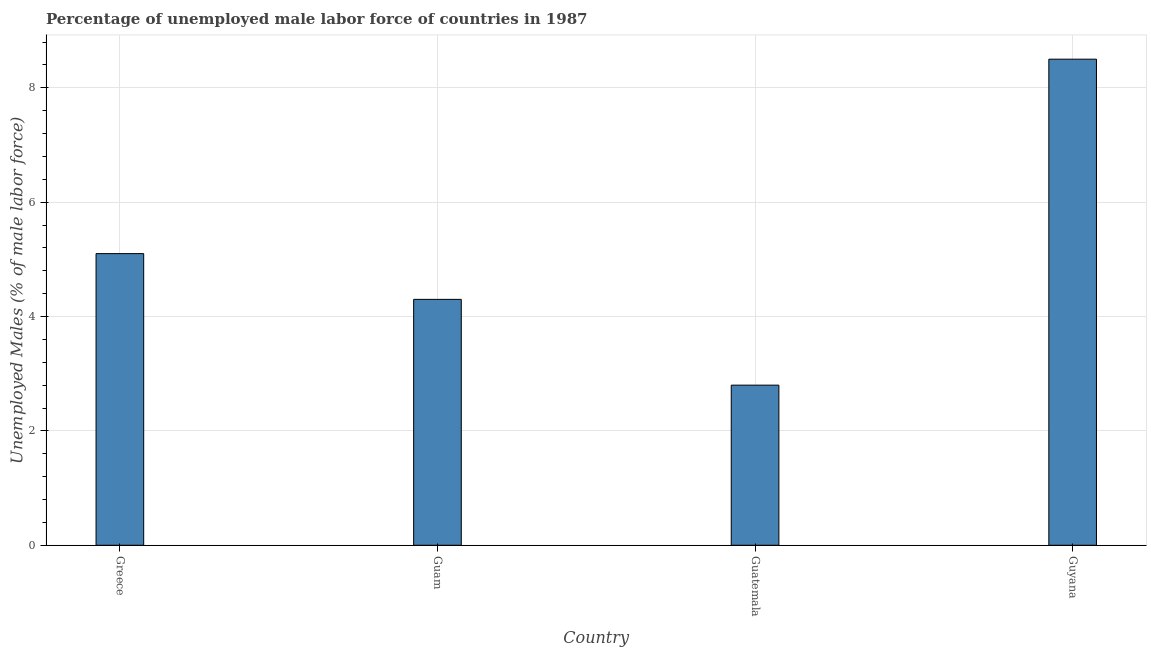What is the title of the graph?
Ensure brevity in your answer.  Percentage of unemployed male labor force of countries in 1987. What is the label or title of the X-axis?
Offer a very short reply. Country. What is the label or title of the Y-axis?
Your answer should be very brief. Unemployed Males (% of male labor force). What is the total unemployed male labour force in Guyana?
Make the answer very short. 8.5. Across all countries, what is the minimum total unemployed male labour force?
Offer a terse response. 2.8. In which country was the total unemployed male labour force maximum?
Provide a succinct answer. Guyana. In which country was the total unemployed male labour force minimum?
Provide a short and direct response. Guatemala. What is the sum of the total unemployed male labour force?
Your answer should be very brief. 20.7. What is the average total unemployed male labour force per country?
Give a very brief answer. 5.17. What is the median total unemployed male labour force?
Ensure brevity in your answer.  4.7. In how many countries, is the total unemployed male labour force greater than 7.2 %?
Make the answer very short. 1. What is the ratio of the total unemployed male labour force in Guam to that in Guatemala?
Provide a short and direct response. 1.54. Is the difference between the total unemployed male labour force in Guam and Guyana greater than the difference between any two countries?
Provide a short and direct response. No. What is the difference between the highest and the second highest total unemployed male labour force?
Offer a terse response. 3.4. What is the difference between the highest and the lowest total unemployed male labour force?
Offer a very short reply. 5.7. How many countries are there in the graph?
Offer a very short reply. 4. Are the values on the major ticks of Y-axis written in scientific E-notation?
Offer a terse response. No. What is the Unemployed Males (% of male labor force) in Greece?
Make the answer very short. 5.1. What is the Unemployed Males (% of male labor force) in Guam?
Keep it short and to the point. 4.3. What is the Unemployed Males (% of male labor force) of Guatemala?
Offer a terse response. 2.8. What is the difference between the Unemployed Males (% of male labor force) in Greece and Guatemala?
Ensure brevity in your answer.  2.3. What is the difference between the Unemployed Males (% of male labor force) in Greece and Guyana?
Give a very brief answer. -3.4. What is the ratio of the Unemployed Males (% of male labor force) in Greece to that in Guam?
Your answer should be very brief. 1.19. What is the ratio of the Unemployed Males (% of male labor force) in Greece to that in Guatemala?
Provide a short and direct response. 1.82. What is the ratio of the Unemployed Males (% of male labor force) in Greece to that in Guyana?
Ensure brevity in your answer.  0.6. What is the ratio of the Unemployed Males (% of male labor force) in Guam to that in Guatemala?
Ensure brevity in your answer.  1.54. What is the ratio of the Unemployed Males (% of male labor force) in Guam to that in Guyana?
Provide a short and direct response. 0.51. What is the ratio of the Unemployed Males (% of male labor force) in Guatemala to that in Guyana?
Make the answer very short. 0.33. 